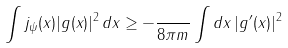<formula> <loc_0><loc_0><loc_500><loc_500>\int j _ { \psi } ( x ) | g ( x ) | ^ { 2 } \, d x \geq - \frac { } { 8 \pi m } \int d x \, | g ^ { \prime } ( x ) | ^ { 2 }</formula> 